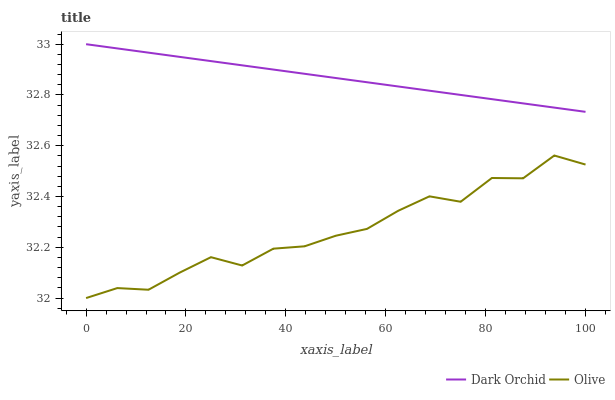Does Olive have the minimum area under the curve?
Answer yes or no. Yes. Does Dark Orchid have the maximum area under the curve?
Answer yes or no. Yes. Does Dark Orchid have the minimum area under the curve?
Answer yes or no. No. Is Dark Orchid the smoothest?
Answer yes or no. Yes. Is Olive the roughest?
Answer yes or no. Yes. Is Dark Orchid the roughest?
Answer yes or no. No. Does Olive have the lowest value?
Answer yes or no. Yes. Does Dark Orchid have the lowest value?
Answer yes or no. No. Does Dark Orchid have the highest value?
Answer yes or no. Yes. Is Olive less than Dark Orchid?
Answer yes or no. Yes. Is Dark Orchid greater than Olive?
Answer yes or no. Yes. Does Olive intersect Dark Orchid?
Answer yes or no. No. 